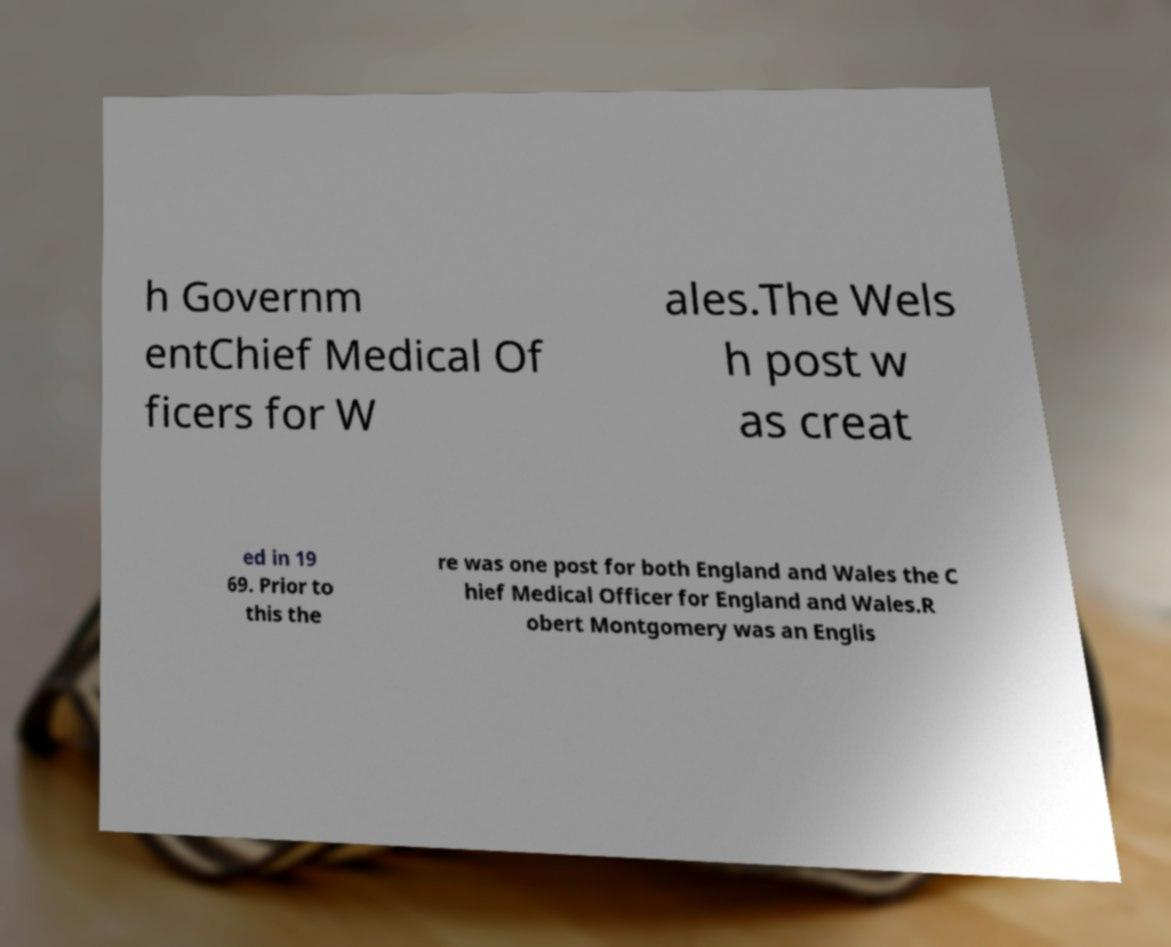For documentation purposes, I need the text within this image transcribed. Could you provide that? h Governm entChief Medical Of ficers for W ales.The Wels h post w as creat ed in 19 69. Prior to this the re was one post for both England and Wales the C hief Medical Officer for England and Wales.R obert Montgomery was an Englis 